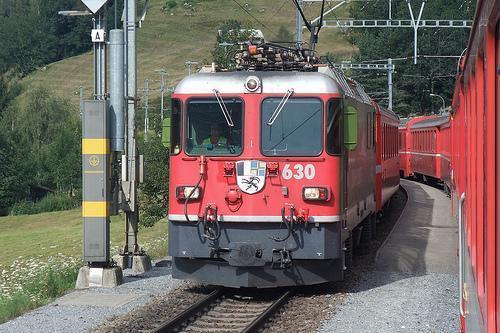How many people are in the photo?
Give a very brief answer. 1. 